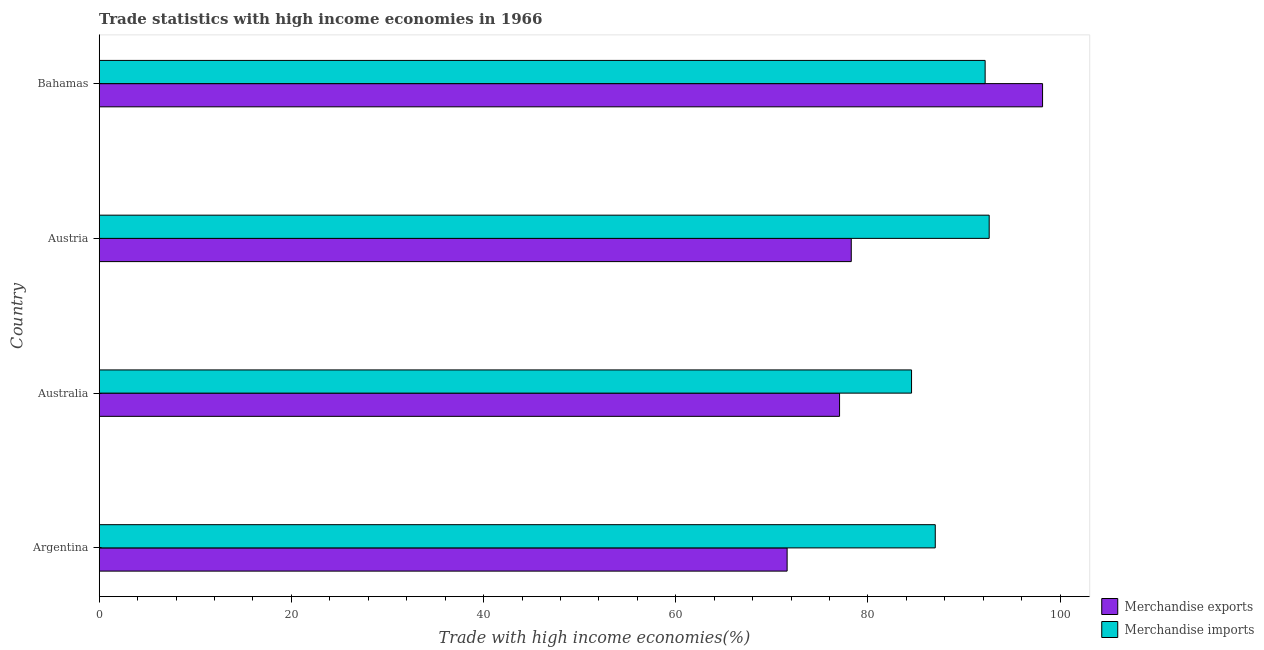How many groups of bars are there?
Make the answer very short. 4. Are the number of bars per tick equal to the number of legend labels?
Offer a very short reply. Yes. Are the number of bars on each tick of the Y-axis equal?
Provide a succinct answer. Yes. How many bars are there on the 3rd tick from the top?
Provide a short and direct response. 2. How many bars are there on the 1st tick from the bottom?
Offer a terse response. 2. What is the label of the 1st group of bars from the top?
Provide a succinct answer. Bahamas. In how many cases, is the number of bars for a given country not equal to the number of legend labels?
Your answer should be compact. 0. What is the merchandise imports in Argentina?
Make the answer very short. 87.01. Across all countries, what is the maximum merchandise exports?
Provide a succinct answer. 98.17. Across all countries, what is the minimum merchandise exports?
Make the answer very short. 71.59. In which country was the merchandise exports minimum?
Make the answer very short. Argentina. What is the total merchandise imports in the graph?
Provide a short and direct response. 356.36. What is the difference between the merchandise exports in Australia and that in Bahamas?
Your answer should be compact. -21.13. What is the difference between the merchandise exports in Australia and the merchandise imports in Austria?
Make the answer very short. -15.57. What is the average merchandise imports per country?
Keep it short and to the point. 89.09. What is the difference between the merchandise imports and merchandise exports in Argentina?
Make the answer very short. 15.42. In how many countries, is the merchandise imports greater than 40 %?
Your answer should be very brief. 4. Is the merchandise imports in Austria less than that in Bahamas?
Your answer should be compact. No. What is the difference between the highest and the second highest merchandise imports?
Your answer should be compact. 0.42. What is the difference between the highest and the lowest merchandise exports?
Keep it short and to the point. 26.58. What does the 2nd bar from the top in Argentina represents?
Offer a very short reply. Merchandise exports. Are all the bars in the graph horizontal?
Make the answer very short. Yes. How many countries are there in the graph?
Make the answer very short. 4. What is the difference between two consecutive major ticks on the X-axis?
Provide a succinct answer. 20. Does the graph contain any zero values?
Make the answer very short. No. Where does the legend appear in the graph?
Make the answer very short. Bottom right. How many legend labels are there?
Offer a very short reply. 2. How are the legend labels stacked?
Give a very brief answer. Vertical. What is the title of the graph?
Offer a terse response. Trade statistics with high income economies in 1966. Does "From human activities" appear as one of the legend labels in the graph?
Provide a succinct answer. No. What is the label or title of the X-axis?
Offer a terse response. Trade with high income economies(%). What is the label or title of the Y-axis?
Offer a terse response. Country. What is the Trade with high income economies(%) of Merchandise exports in Argentina?
Your answer should be compact. 71.59. What is the Trade with high income economies(%) in Merchandise imports in Argentina?
Make the answer very short. 87.01. What is the Trade with high income economies(%) in Merchandise exports in Australia?
Provide a short and direct response. 77.05. What is the Trade with high income economies(%) in Merchandise imports in Australia?
Your answer should be very brief. 84.54. What is the Trade with high income economies(%) of Merchandise exports in Austria?
Give a very brief answer. 78.27. What is the Trade with high income economies(%) of Merchandise imports in Austria?
Your response must be concise. 92.62. What is the Trade with high income economies(%) of Merchandise exports in Bahamas?
Offer a terse response. 98.17. What is the Trade with high income economies(%) in Merchandise imports in Bahamas?
Make the answer very short. 92.2. Across all countries, what is the maximum Trade with high income economies(%) in Merchandise exports?
Your answer should be very brief. 98.17. Across all countries, what is the maximum Trade with high income economies(%) of Merchandise imports?
Provide a short and direct response. 92.62. Across all countries, what is the minimum Trade with high income economies(%) in Merchandise exports?
Make the answer very short. 71.59. Across all countries, what is the minimum Trade with high income economies(%) of Merchandise imports?
Provide a succinct answer. 84.54. What is the total Trade with high income economies(%) of Merchandise exports in the graph?
Give a very brief answer. 325.08. What is the total Trade with high income economies(%) of Merchandise imports in the graph?
Keep it short and to the point. 356.36. What is the difference between the Trade with high income economies(%) of Merchandise exports in Argentina and that in Australia?
Your answer should be very brief. -5.46. What is the difference between the Trade with high income economies(%) of Merchandise imports in Argentina and that in Australia?
Give a very brief answer. 2.47. What is the difference between the Trade with high income economies(%) in Merchandise exports in Argentina and that in Austria?
Your response must be concise. -6.68. What is the difference between the Trade with high income economies(%) in Merchandise imports in Argentina and that in Austria?
Ensure brevity in your answer.  -5.61. What is the difference between the Trade with high income economies(%) of Merchandise exports in Argentina and that in Bahamas?
Offer a terse response. -26.58. What is the difference between the Trade with high income economies(%) of Merchandise imports in Argentina and that in Bahamas?
Your answer should be compact. -5.19. What is the difference between the Trade with high income economies(%) of Merchandise exports in Australia and that in Austria?
Give a very brief answer. -1.22. What is the difference between the Trade with high income economies(%) of Merchandise imports in Australia and that in Austria?
Your answer should be compact. -8.08. What is the difference between the Trade with high income economies(%) of Merchandise exports in Australia and that in Bahamas?
Your answer should be compact. -21.13. What is the difference between the Trade with high income economies(%) of Merchandise imports in Australia and that in Bahamas?
Your response must be concise. -7.66. What is the difference between the Trade with high income economies(%) of Merchandise exports in Austria and that in Bahamas?
Your answer should be very brief. -19.91. What is the difference between the Trade with high income economies(%) in Merchandise imports in Austria and that in Bahamas?
Keep it short and to the point. 0.42. What is the difference between the Trade with high income economies(%) of Merchandise exports in Argentina and the Trade with high income economies(%) of Merchandise imports in Australia?
Provide a short and direct response. -12.95. What is the difference between the Trade with high income economies(%) in Merchandise exports in Argentina and the Trade with high income economies(%) in Merchandise imports in Austria?
Ensure brevity in your answer.  -21.03. What is the difference between the Trade with high income economies(%) in Merchandise exports in Argentina and the Trade with high income economies(%) in Merchandise imports in Bahamas?
Make the answer very short. -20.61. What is the difference between the Trade with high income economies(%) in Merchandise exports in Australia and the Trade with high income economies(%) in Merchandise imports in Austria?
Offer a terse response. -15.57. What is the difference between the Trade with high income economies(%) in Merchandise exports in Australia and the Trade with high income economies(%) in Merchandise imports in Bahamas?
Give a very brief answer. -15.15. What is the difference between the Trade with high income economies(%) of Merchandise exports in Austria and the Trade with high income economies(%) of Merchandise imports in Bahamas?
Ensure brevity in your answer.  -13.93. What is the average Trade with high income economies(%) in Merchandise exports per country?
Keep it short and to the point. 81.27. What is the average Trade with high income economies(%) in Merchandise imports per country?
Keep it short and to the point. 89.09. What is the difference between the Trade with high income economies(%) of Merchandise exports and Trade with high income economies(%) of Merchandise imports in Argentina?
Keep it short and to the point. -15.42. What is the difference between the Trade with high income economies(%) of Merchandise exports and Trade with high income economies(%) of Merchandise imports in Australia?
Give a very brief answer. -7.49. What is the difference between the Trade with high income economies(%) in Merchandise exports and Trade with high income economies(%) in Merchandise imports in Austria?
Make the answer very short. -14.35. What is the difference between the Trade with high income economies(%) in Merchandise exports and Trade with high income economies(%) in Merchandise imports in Bahamas?
Your answer should be very brief. 5.98. What is the ratio of the Trade with high income economies(%) in Merchandise exports in Argentina to that in Australia?
Make the answer very short. 0.93. What is the ratio of the Trade with high income economies(%) of Merchandise imports in Argentina to that in Australia?
Provide a short and direct response. 1.03. What is the ratio of the Trade with high income economies(%) in Merchandise exports in Argentina to that in Austria?
Your response must be concise. 0.91. What is the ratio of the Trade with high income economies(%) in Merchandise imports in Argentina to that in Austria?
Offer a very short reply. 0.94. What is the ratio of the Trade with high income economies(%) in Merchandise exports in Argentina to that in Bahamas?
Keep it short and to the point. 0.73. What is the ratio of the Trade with high income economies(%) of Merchandise imports in Argentina to that in Bahamas?
Give a very brief answer. 0.94. What is the ratio of the Trade with high income economies(%) of Merchandise exports in Australia to that in Austria?
Your response must be concise. 0.98. What is the ratio of the Trade with high income economies(%) of Merchandise imports in Australia to that in Austria?
Ensure brevity in your answer.  0.91. What is the ratio of the Trade with high income economies(%) of Merchandise exports in Australia to that in Bahamas?
Make the answer very short. 0.78. What is the ratio of the Trade with high income economies(%) of Merchandise imports in Australia to that in Bahamas?
Offer a very short reply. 0.92. What is the ratio of the Trade with high income economies(%) of Merchandise exports in Austria to that in Bahamas?
Your answer should be compact. 0.8. What is the difference between the highest and the second highest Trade with high income economies(%) in Merchandise exports?
Your answer should be compact. 19.91. What is the difference between the highest and the second highest Trade with high income economies(%) in Merchandise imports?
Give a very brief answer. 0.42. What is the difference between the highest and the lowest Trade with high income economies(%) in Merchandise exports?
Give a very brief answer. 26.58. What is the difference between the highest and the lowest Trade with high income economies(%) of Merchandise imports?
Your answer should be very brief. 8.08. 